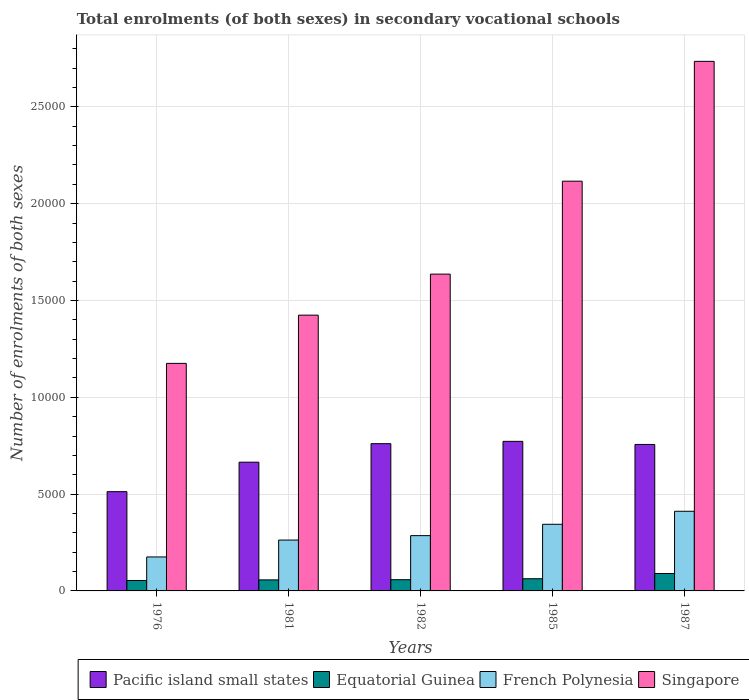How many bars are there on the 4th tick from the right?
Your answer should be very brief. 4. What is the label of the 2nd group of bars from the left?
Your answer should be compact. 1981. What is the number of enrolments in secondary schools in Equatorial Guinea in 1981?
Your response must be concise. 570. Across all years, what is the maximum number of enrolments in secondary schools in Pacific island small states?
Make the answer very short. 7724.29. Across all years, what is the minimum number of enrolments in secondary schools in French Polynesia?
Provide a short and direct response. 1755. In which year was the number of enrolments in secondary schools in Singapore minimum?
Your answer should be very brief. 1976. What is the total number of enrolments in secondary schools in French Polynesia in the graph?
Your answer should be compact. 1.48e+04. What is the difference between the number of enrolments in secondary schools in Pacific island small states in 1976 and that in 1981?
Your response must be concise. -1522.4. What is the difference between the number of enrolments in secondary schools in Pacific island small states in 1987 and the number of enrolments in secondary schools in Equatorial Guinea in 1985?
Your answer should be compact. 6934.79. What is the average number of enrolments in secondary schools in Singapore per year?
Provide a succinct answer. 1.82e+04. In the year 1982, what is the difference between the number of enrolments in secondary schools in French Polynesia and number of enrolments in secondary schools in Singapore?
Make the answer very short. -1.35e+04. What is the ratio of the number of enrolments in secondary schools in Singapore in 1976 to that in 1981?
Make the answer very short. 0.83. Is the difference between the number of enrolments in secondary schools in French Polynesia in 1981 and 1982 greater than the difference between the number of enrolments in secondary schools in Singapore in 1981 and 1982?
Provide a succinct answer. Yes. What is the difference between the highest and the second highest number of enrolments in secondary schools in French Polynesia?
Offer a very short reply. 672. What is the difference between the highest and the lowest number of enrolments in secondary schools in Equatorial Guinea?
Offer a terse response. 361. Is the sum of the number of enrolments in secondary schools in Equatorial Guinea in 1982 and 1987 greater than the maximum number of enrolments in secondary schools in Pacific island small states across all years?
Provide a succinct answer. No. Is it the case that in every year, the sum of the number of enrolments in secondary schools in French Polynesia and number of enrolments in secondary schools in Pacific island small states is greater than the sum of number of enrolments in secondary schools in Singapore and number of enrolments in secondary schools in Equatorial Guinea?
Give a very brief answer. No. What does the 4th bar from the left in 1981 represents?
Your answer should be very brief. Singapore. What does the 4th bar from the right in 1985 represents?
Give a very brief answer. Pacific island small states. How many bars are there?
Give a very brief answer. 20. Are all the bars in the graph horizontal?
Ensure brevity in your answer.  No. Are the values on the major ticks of Y-axis written in scientific E-notation?
Your answer should be compact. No. Does the graph contain any zero values?
Keep it short and to the point. No. What is the title of the graph?
Offer a terse response. Total enrolments (of both sexes) in secondary vocational schools. Does "Tuvalu" appear as one of the legend labels in the graph?
Your response must be concise. No. What is the label or title of the Y-axis?
Your response must be concise. Number of enrolments of both sexes. What is the Number of enrolments of both sexes in Pacific island small states in 1976?
Keep it short and to the point. 5126.3. What is the Number of enrolments of both sexes of Equatorial Guinea in 1976?
Offer a terse response. 539. What is the Number of enrolments of both sexes of French Polynesia in 1976?
Provide a short and direct response. 1755. What is the Number of enrolments of both sexes in Singapore in 1976?
Your answer should be very brief. 1.18e+04. What is the Number of enrolments of both sexes in Pacific island small states in 1981?
Ensure brevity in your answer.  6648.7. What is the Number of enrolments of both sexes of Equatorial Guinea in 1981?
Your answer should be very brief. 570. What is the Number of enrolments of both sexes in French Polynesia in 1981?
Your response must be concise. 2627. What is the Number of enrolments of both sexes of Singapore in 1981?
Your answer should be compact. 1.42e+04. What is the Number of enrolments of both sexes of Pacific island small states in 1982?
Offer a very short reply. 7604.77. What is the Number of enrolments of both sexes in Equatorial Guinea in 1982?
Give a very brief answer. 580. What is the Number of enrolments of both sexes of French Polynesia in 1982?
Offer a very short reply. 2855. What is the Number of enrolments of both sexes in Singapore in 1982?
Offer a terse response. 1.64e+04. What is the Number of enrolments of both sexes of Pacific island small states in 1985?
Your answer should be compact. 7724.29. What is the Number of enrolments of both sexes in Equatorial Guinea in 1985?
Make the answer very short. 630. What is the Number of enrolments of both sexes of French Polynesia in 1985?
Provide a succinct answer. 3441. What is the Number of enrolments of both sexes in Singapore in 1985?
Offer a terse response. 2.12e+04. What is the Number of enrolments of both sexes of Pacific island small states in 1987?
Your answer should be compact. 7564.79. What is the Number of enrolments of both sexes in Equatorial Guinea in 1987?
Ensure brevity in your answer.  900. What is the Number of enrolments of both sexes in French Polynesia in 1987?
Your response must be concise. 4113. What is the Number of enrolments of both sexes in Singapore in 1987?
Provide a short and direct response. 2.73e+04. Across all years, what is the maximum Number of enrolments of both sexes in Pacific island small states?
Keep it short and to the point. 7724.29. Across all years, what is the maximum Number of enrolments of both sexes of Equatorial Guinea?
Give a very brief answer. 900. Across all years, what is the maximum Number of enrolments of both sexes in French Polynesia?
Provide a short and direct response. 4113. Across all years, what is the maximum Number of enrolments of both sexes of Singapore?
Offer a very short reply. 2.73e+04. Across all years, what is the minimum Number of enrolments of both sexes in Pacific island small states?
Ensure brevity in your answer.  5126.3. Across all years, what is the minimum Number of enrolments of both sexes of Equatorial Guinea?
Provide a succinct answer. 539. Across all years, what is the minimum Number of enrolments of both sexes of French Polynesia?
Provide a short and direct response. 1755. Across all years, what is the minimum Number of enrolments of both sexes in Singapore?
Give a very brief answer. 1.18e+04. What is the total Number of enrolments of both sexes of Pacific island small states in the graph?
Your answer should be compact. 3.47e+04. What is the total Number of enrolments of both sexes of Equatorial Guinea in the graph?
Offer a very short reply. 3219. What is the total Number of enrolments of both sexes in French Polynesia in the graph?
Your answer should be very brief. 1.48e+04. What is the total Number of enrolments of both sexes in Singapore in the graph?
Keep it short and to the point. 9.09e+04. What is the difference between the Number of enrolments of both sexes of Pacific island small states in 1976 and that in 1981?
Your answer should be very brief. -1522.4. What is the difference between the Number of enrolments of both sexes in Equatorial Guinea in 1976 and that in 1981?
Offer a very short reply. -31. What is the difference between the Number of enrolments of both sexes of French Polynesia in 1976 and that in 1981?
Ensure brevity in your answer.  -872. What is the difference between the Number of enrolments of both sexes of Singapore in 1976 and that in 1981?
Your response must be concise. -2491. What is the difference between the Number of enrolments of both sexes in Pacific island small states in 1976 and that in 1982?
Your answer should be very brief. -2478.46. What is the difference between the Number of enrolments of both sexes of Equatorial Guinea in 1976 and that in 1982?
Offer a very short reply. -41. What is the difference between the Number of enrolments of both sexes in French Polynesia in 1976 and that in 1982?
Offer a terse response. -1100. What is the difference between the Number of enrolments of both sexes in Singapore in 1976 and that in 1982?
Keep it short and to the point. -4610. What is the difference between the Number of enrolments of both sexes of Pacific island small states in 1976 and that in 1985?
Provide a short and direct response. -2597.98. What is the difference between the Number of enrolments of both sexes in Equatorial Guinea in 1976 and that in 1985?
Your response must be concise. -91. What is the difference between the Number of enrolments of both sexes of French Polynesia in 1976 and that in 1985?
Give a very brief answer. -1686. What is the difference between the Number of enrolments of both sexes of Singapore in 1976 and that in 1985?
Provide a succinct answer. -9410. What is the difference between the Number of enrolments of both sexes of Pacific island small states in 1976 and that in 1987?
Your answer should be compact. -2438.49. What is the difference between the Number of enrolments of both sexes in Equatorial Guinea in 1976 and that in 1987?
Provide a short and direct response. -361. What is the difference between the Number of enrolments of both sexes in French Polynesia in 1976 and that in 1987?
Your answer should be very brief. -2358. What is the difference between the Number of enrolments of both sexes of Singapore in 1976 and that in 1987?
Offer a very short reply. -1.56e+04. What is the difference between the Number of enrolments of both sexes in Pacific island small states in 1981 and that in 1982?
Your answer should be very brief. -956.06. What is the difference between the Number of enrolments of both sexes of French Polynesia in 1981 and that in 1982?
Make the answer very short. -228. What is the difference between the Number of enrolments of both sexes in Singapore in 1981 and that in 1982?
Offer a very short reply. -2119. What is the difference between the Number of enrolments of both sexes of Pacific island small states in 1981 and that in 1985?
Provide a succinct answer. -1075.59. What is the difference between the Number of enrolments of both sexes of Equatorial Guinea in 1981 and that in 1985?
Keep it short and to the point. -60. What is the difference between the Number of enrolments of both sexes of French Polynesia in 1981 and that in 1985?
Your response must be concise. -814. What is the difference between the Number of enrolments of both sexes of Singapore in 1981 and that in 1985?
Keep it short and to the point. -6919. What is the difference between the Number of enrolments of both sexes in Pacific island small states in 1981 and that in 1987?
Make the answer very short. -916.09. What is the difference between the Number of enrolments of both sexes in Equatorial Guinea in 1981 and that in 1987?
Keep it short and to the point. -330. What is the difference between the Number of enrolments of both sexes of French Polynesia in 1981 and that in 1987?
Offer a very short reply. -1486. What is the difference between the Number of enrolments of both sexes of Singapore in 1981 and that in 1987?
Your answer should be compact. -1.31e+04. What is the difference between the Number of enrolments of both sexes in Pacific island small states in 1982 and that in 1985?
Keep it short and to the point. -119.52. What is the difference between the Number of enrolments of both sexes of French Polynesia in 1982 and that in 1985?
Your response must be concise. -586. What is the difference between the Number of enrolments of both sexes of Singapore in 1982 and that in 1985?
Provide a succinct answer. -4800. What is the difference between the Number of enrolments of both sexes of Pacific island small states in 1982 and that in 1987?
Keep it short and to the point. 39.98. What is the difference between the Number of enrolments of both sexes of Equatorial Guinea in 1982 and that in 1987?
Your answer should be compact. -320. What is the difference between the Number of enrolments of both sexes of French Polynesia in 1982 and that in 1987?
Offer a terse response. -1258. What is the difference between the Number of enrolments of both sexes in Singapore in 1982 and that in 1987?
Offer a terse response. -1.10e+04. What is the difference between the Number of enrolments of both sexes in Pacific island small states in 1985 and that in 1987?
Your answer should be compact. 159.5. What is the difference between the Number of enrolments of both sexes of Equatorial Guinea in 1985 and that in 1987?
Your response must be concise. -270. What is the difference between the Number of enrolments of both sexes of French Polynesia in 1985 and that in 1987?
Your answer should be compact. -672. What is the difference between the Number of enrolments of both sexes of Singapore in 1985 and that in 1987?
Give a very brief answer. -6188. What is the difference between the Number of enrolments of both sexes of Pacific island small states in 1976 and the Number of enrolments of both sexes of Equatorial Guinea in 1981?
Provide a succinct answer. 4556.3. What is the difference between the Number of enrolments of both sexes in Pacific island small states in 1976 and the Number of enrolments of both sexes in French Polynesia in 1981?
Offer a very short reply. 2499.3. What is the difference between the Number of enrolments of both sexes in Pacific island small states in 1976 and the Number of enrolments of both sexes in Singapore in 1981?
Ensure brevity in your answer.  -9115.7. What is the difference between the Number of enrolments of both sexes of Equatorial Guinea in 1976 and the Number of enrolments of both sexes of French Polynesia in 1981?
Provide a succinct answer. -2088. What is the difference between the Number of enrolments of both sexes of Equatorial Guinea in 1976 and the Number of enrolments of both sexes of Singapore in 1981?
Give a very brief answer. -1.37e+04. What is the difference between the Number of enrolments of both sexes in French Polynesia in 1976 and the Number of enrolments of both sexes in Singapore in 1981?
Give a very brief answer. -1.25e+04. What is the difference between the Number of enrolments of both sexes of Pacific island small states in 1976 and the Number of enrolments of both sexes of Equatorial Guinea in 1982?
Provide a short and direct response. 4546.3. What is the difference between the Number of enrolments of both sexes of Pacific island small states in 1976 and the Number of enrolments of both sexes of French Polynesia in 1982?
Your answer should be compact. 2271.3. What is the difference between the Number of enrolments of both sexes of Pacific island small states in 1976 and the Number of enrolments of both sexes of Singapore in 1982?
Your answer should be compact. -1.12e+04. What is the difference between the Number of enrolments of both sexes in Equatorial Guinea in 1976 and the Number of enrolments of both sexes in French Polynesia in 1982?
Give a very brief answer. -2316. What is the difference between the Number of enrolments of both sexes of Equatorial Guinea in 1976 and the Number of enrolments of both sexes of Singapore in 1982?
Your answer should be compact. -1.58e+04. What is the difference between the Number of enrolments of both sexes in French Polynesia in 1976 and the Number of enrolments of both sexes in Singapore in 1982?
Offer a very short reply. -1.46e+04. What is the difference between the Number of enrolments of both sexes of Pacific island small states in 1976 and the Number of enrolments of both sexes of Equatorial Guinea in 1985?
Provide a short and direct response. 4496.3. What is the difference between the Number of enrolments of both sexes in Pacific island small states in 1976 and the Number of enrolments of both sexes in French Polynesia in 1985?
Offer a terse response. 1685.3. What is the difference between the Number of enrolments of both sexes of Pacific island small states in 1976 and the Number of enrolments of both sexes of Singapore in 1985?
Ensure brevity in your answer.  -1.60e+04. What is the difference between the Number of enrolments of both sexes in Equatorial Guinea in 1976 and the Number of enrolments of both sexes in French Polynesia in 1985?
Give a very brief answer. -2902. What is the difference between the Number of enrolments of both sexes of Equatorial Guinea in 1976 and the Number of enrolments of both sexes of Singapore in 1985?
Your answer should be compact. -2.06e+04. What is the difference between the Number of enrolments of both sexes of French Polynesia in 1976 and the Number of enrolments of both sexes of Singapore in 1985?
Keep it short and to the point. -1.94e+04. What is the difference between the Number of enrolments of both sexes in Pacific island small states in 1976 and the Number of enrolments of both sexes in Equatorial Guinea in 1987?
Give a very brief answer. 4226.3. What is the difference between the Number of enrolments of both sexes of Pacific island small states in 1976 and the Number of enrolments of both sexes of French Polynesia in 1987?
Give a very brief answer. 1013.3. What is the difference between the Number of enrolments of both sexes of Pacific island small states in 1976 and the Number of enrolments of both sexes of Singapore in 1987?
Your answer should be compact. -2.22e+04. What is the difference between the Number of enrolments of both sexes of Equatorial Guinea in 1976 and the Number of enrolments of both sexes of French Polynesia in 1987?
Your answer should be very brief. -3574. What is the difference between the Number of enrolments of both sexes of Equatorial Guinea in 1976 and the Number of enrolments of both sexes of Singapore in 1987?
Make the answer very short. -2.68e+04. What is the difference between the Number of enrolments of both sexes in French Polynesia in 1976 and the Number of enrolments of both sexes in Singapore in 1987?
Provide a succinct answer. -2.56e+04. What is the difference between the Number of enrolments of both sexes of Pacific island small states in 1981 and the Number of enrolments of both sexes of Equatorial Guinea in 1982?
Keep it short and to the point. 6068.7. What is the difference between the Number of enrolments of both sexes of Pacific island small states in 1981 and the Number of enrolments of both sexes of French Polynesia in 1982?
Offer a terse response. 3793.7. What is the difference between the Number of enrolments of both sexes of Pacific island small states in 1981 and the Number of enrolments of both sexes of Singapore in 1982?
Give a very brief answer. -9712.3. What is the difference between the Number of enrolments of both sexes in Equatorial Guinea in 1981 and the Number of enrolments of both sexes in French Polynesia in 1982?
Provide a succinct answer. -2285. What is the difference between the Number of enrolments of both sexes of Equatorial Guinea in 1981 and the Number of enrolments of both sexes of Singapore in 1982?
Provide a succinct answer. -1.58e+04. What is the difference between the Number of enrolments of both sexes in French Polynesia in 1981 and the Number of enrolments of both sexes in Singapore in 1982?
Give a very brief answer. -1.37e+04. What is the difference between the Number of enrolments of both sexes in Pacific island small states in 1981 and the Number of enrolments of both sexes in Equatorial Guinea in 1985?
Offer a terse response. 6018.7. What is the difference between the Number of enrolments of both sexes in Pacific island small states in 1981 and the Number of enrolments of both sexes in French Polynesia in 1985?
Ensure brevity in your answer.  3207.7. What is the difference between the Number of enrolments of both sexes of Pacific island small states in 1981 and the Number of enrolments of both sexes of Singapore in 1985?
Offer a very short reply. -1.45e+04. What is the difference between the Number of enrolments of both sexes of Equatorial Guinea in 1981 and the Number of enrolments of both sexes of French Polynesia in 1985?
Keep it short and to the point. -2871. What is the difference between the Number of enrolments of both sexes in Equatorial Guinea in 1981 and the Number of enrolments of both sexes in Singapore in 1985?
Provide a succinct answer. -2.06e+04. What is the difference between the Number of enrolments of both sexes of French Polynesia in 1981 and the Number of enrolments of both sexes of Singapore in 1985?
Ensure brevity in your answer.  -1.85e+04. What is the difference between the Number of enrolments of both sexes of Pacific island small states in 1981 and the Number of enrolments of both sexes of Equatorial Guinea in 1987?
Give a very brief answer. 5748.7. What is the difference between the Number of enrolments of both sexes of Pacific island small states in 1981 and the Number of enrolments of both sexes of French Polynesia in 1987?
Provide a succinct answer. 2535.7. What is the difference between the Number of enrolments of both sexes in Pacific island small states in 1981 and the Number of enrolments of both sexes in Singapore in 1987?
Ensure brevity in your answer.  -2.07e+04. What is the difference between the Number of enrolments of both sexes in Equatorial Guinea in 1981 and the Number of enrolments of both sexes in French Polynesia in 1987?
Your response must be concise. -3543. What is the difference between the Number of enrolments of both sexes in Equatorial Guinea in 1981 and the Number of enrolments of both sexes in Singapore in 1987?
Provide a succinct answer. -2.68e+04. What is the difference between the Number of enrolments of both sexes of French Polynesia in 1981 and the Number of enrolments of both sexes of Singapore in 1987?
Offer a terse response. -2.47e+04. What is the difference between the Number of enrolments of both sexes of Pacific island small states in 1982 and the Number of enrolments of both sexes of Equatorial Guinea in 1985?
Give a very brief answer. 6974.77. What is the difference between the Number of enrolments of both sexes in Pacific island small states in 1982 and the Number of enrolments of both sexes in French Polynesia in 1985?
Provide a short and direct response. 4163.77. What is the difference between the Number of enrolments of both sexes in Pacific island small states in 1982 and the Number of enrolments of both sexes in Singapore in 1985?
Offer a terse response. -1.36e+04. What is the difference between the Number of enrolments of both sexes in Equatorial Guinea in 1982 and the Number of enrolments of both sexes in French Polynesia in 1985?
Your answer should be compact. -2861. What is the difference between the Number of enrolments of both sexes in Equatorial Guinea in 1982 and the Number of enrolments of both sexes in Singapore in 1985?
Provide a short and direct response. -2.06e+04. What is the difference between the Number of enrolments of both sexes of French Polynesia in 1982 and the Number of enrolments of both sexes of Singapore in 1985?
Ensure brevity in your answer.  -1.83e+04. What is the difference between the Number of enrolments of both sexes of Pacific island small states in 1982 and the Number of enrolments of both sexes of Equatorial Guinea in 1987?
Provide a succinct answer. 6704.77. What is the difference between the Number of enrolments of both sexes of Pacific island small states in 1982 and the Number of enrolments of both sexes of French Polynesia in 1987?
Make the answer very short. 3491.77. What is the difference between the Number of enrolments of both sexes of Pacific island small states in 1982 and the Number of enrolments of both sexes of Singapore in 1987?
Your answer should be compact. -1.97e+04. What is the difference between the Number of enrolments of both sexes in Equatorial Guinea in 1982 and the Number of enrolments of both sexes in French Polynesia in 1987?
Give a very brief answer. -3533. What is the difference between the Number of enrolments of both sexes of Equatorial Guinea in 1982 and the Number of enrolments of both sexes of Singapore in 1987?
Offer a terse response. -2.68e+04. What is the difference between the Number of enrolments of both sexes of French Polynesia in 1982 and the Number of enrolments of both sexes of Singapore in 1987?
Your answer should be very brief. -2.45e+04. What is the difference between the Number of enrolments of both sexes in Pacific island small states in 1985 and the Number of enrolments of both sexes in Equatorial Guinea in 1987?
Your answer should be very brief. 6824.29. What is the difference between the Number of enrolments of both sexes in Pacific island small states in 1985 and the Number of enrolments of both sexes in French Polynesia in 1987?
Provide a succinct answer. 3611.29. What is the difference between the Number of enrolments of both sexes of Pacific island small states in 1985 and the Number of enrolments of both sexes of Singapore in 1987?
Offer a very short reply. -1.96e+04. What is the difference between the Number of enrolments of both sexes of Equatorial Guinea in 1985 and the Number of enrolments of both sexes of French Polynesia in 1987?
Provide a short and direct response. -3483. What is the difference between the Number of enrolments of both sexes of Equatorial Guinea in 1985 and the Number of enrolments of both sexes of Singapore in 1987?
Provide a short and direct response. -2.67e+04. What is the difference between the Number of enrolments of both sexes in French Polynesia in 1985 and the Number of enrolments of both sexes in Singapore in 1987?
Your answer should be compact. -2.39e+04. What is the average Number of enrolments of both sexes in Pacific island small states per year?
Your response must be concise. 6933.77. What is the average Number of enrolments of both sexes in Equatorial Guinea per year?
Your response must be concise. 643.8. What is the average Number of enrolments of both sexes of French Polynesia per year?
Your response must be concise. 2958.2. What is the average Number of enrolments of both sexes of Singapore per year?
Your answer should be compact. 1.82e+04. In the year 1976, what is the difference between the Number of enrolments of both sexes in Pacific island small states and Number of enrolments of both sexes in Equatorial Guinea?
Your response must be concise. 4587.3. In the year 1976, what is the difference between the Number of enrolments of both sexes in Pacific island small states and Number of enrolments of both sexes in French Polynesia?
Provide a short and direct response. 3371.3. In the year 1976, what is the difference between the Number of enrolments of both sexes in Pacific island small states and Number of enrolments of both sexes in Singapore?
Keep it short and to the point. -6624.7. In the year 1976, what is the difference between the Number of enrolments of both sexes in Equatorial Guinea and Number of enrolments of both sexes in French Polynesia?
Give a very brief answer. -1216. In the year 1976, what is the difference between the Number of enrolments of both sexes in Equatorial Guinea and Number of enrolments of both sexes in Singapore?
Offer a very short reply. -1.12e+04. In the year 1976, what is the difference between the Number of enrolments of both sexes in French Polynesia and Number of enrolments of both sexes in Singapore?
Your response must be concise. -9996. In the year 1981, what is the difference between the Number of enrolments of both sexes in Pacific island small states and Number of enrolments of both sexes in Equatorial Guinea?
Provide a succinct answer. 6078.7. In the year 1981, what is the difference between the Number of enrolments of both sexes of Pacific island small states and Number of enrolments of both sexes of French Polynesia?
Your response must be concise. 4021.7. In the year 1981, what is the difference between the Number of enrolments of both sexes of Pacific island small states and Number of enrolments of both sexes of Singapore?
Ensure brevity in your answer.  -7593.3. In the year 1981, what is the difference between the Number of enrolments of both sexes in Equatorial Guinea and Number of enrolments of both sexes in French Polynesia?
Ensure brevity in your answer.  -2057. In the year 1981, what is the difference between the Number of enrolments of both sexes in Equatorial Guinea and Number of enrolments of both sexes in Singapore?
Give a very brief answer. -1.37e+04. In the year 1981, what is the difference between the Number of enrolments of both sexes in French Polynesia and Number of enrolments of both sexes in Singapore?
Provide a short and direct response. -1.16e+04. In the year 1982, what is the difference between the Number of enrolments of both sexes of Pacific island small states and Number of enrolments of both sexes of Equatorial Guinea?
Keep it short and to the point. 7024.77. In the year 1982, what is the difference between the Number of enrolments of both sexes of Pacific island small states and Number of enrolments of both sexes of French Polynesia?
Ensure brevity in your answer.  4749.77. In the year 1982, what is the difference between the Number of enrolments of both sexes of Pacific island small states and Number of enrolments of both sexes of Singapore?
Make the answer very short. -8756.23. In the year 1982, what is the difference between the Number of enrolments of both sexes in Equatorial Guinea and Number of enrolments of both sexes in French Polynesia?
Give a very brief answer. -2275. In the year 1982, what is the difference between the Number of enrolments of both sexes of Equatorial Guinea and Number of enrolments of both sexes of Singapore?
Offer a terse response. -1.58e+04. In the year 1982, what is the difference between the Number of enrolments of both sexes in French Polynesia and Number of enrolments of both sexes in Singapore?
Provide a succinct answer. -1.35e+04. In the year 1985, what is the difference between the Number of enrolments of both sexes of Pacific island small states and Number of enrolments of both sexes of Equatorial Guinea?
Provide a short and direct response. 7094.29. In the year 1985, what is the difference between the Number of enrolments of both sexes of Pacific island small states and Number of enrolments of both sexes of French Polynesia?
Offer a terse response. 4283.29. In the year 1985, what is the difference between the Number of enrolments of both sexes in Pacific island small states and Number of enrolments of both sexes in Singapore?
Ensure brevity in your answer.  -1.34e+04. In the year 1985, what is the difference between the Number of enrolments of both sexes in Equatorial Guinea and Number of enrolments of both sexes in French Polynesia?
Give a very brief answer. -2811. In the year 1985, what is the difference between the Number of enrolments of both sexes of Equatorial Guinea and Number of enrolments of both sexes of Singapore?
Your response must be concise. -2.05e+04. In the year 1985, what is the difference between the Number of enrolments of both sexes of French Polynesia and Number of enrolments of both sexes of Singapore?
Ensure brevity in your answer.  -1.77e+04. In the year 1987, what is the difference between the Number of enrolments of both sexes of Pacific island small states and Number of enrolments of both sexes of Equatorial Guinea?
Your answer should be compact. 6664.79. In the year 1987, what is the difference between the Number of enrolments of both sexes in Pacific island small states and Number of enrolments of both sexes in French Polynesia?
Provide a succinct answer. 3451.79. In the year 1987, what is the difference between the Number of enrolments of both sexes of Pacific island small states and Number of enrolments of both sexes of Singapore?
Your answer should be compact. -1.98e+04. In the year 1987, what is the difference between the Number of enrolments of both sexes in Equatorial Guinea and Number of enrolments of both sexes in French Polynesia?
Ensure brevity in your answer.  -3213. In the year 1987, what is the difference between the Number of enrolments of both sexes of Equatorial Guinea and Number of enrolments of both sexes of Singapore?
Your answer should be compact. -2.64e+04. In the year 1987, what is the difference between the Number of enrolments of both sexes in French Polynesia and Number of enrolments of both sexes in Singapore?
Provide a succinct answer. -2.32e+04. What is the ratio of the Number of enrolments of both sexes of Pacific island small states in 1976 to that in 1981?
Keep it short and to the point. 0.77. What is the ratio of the Number of enrolments of both sexes of Equatorial Guinea in 1976 to that in 1981?
Your answer should be very brief. 0.95. What is the ratio of the Number of enrolments of both sexes in French Polynesia in 1976 to that in 1981?
Offer a terse response. 0.67. What is the ratio of the Number of enrolments of both sexes in Singapore in 1976 to that in 1981?
Offer a very short reply. 0.83. What is the ratio of the Number of enrolments of both sexes in Pacific island small states in 1976 to that in 1982?
Your response must be concise. 0.67. What is the ratio of the Number of enrolments of both sexes in Equatorial Guinea in 1976 to that in 1982?
Make the answer very short. 0.93. What is the ratio of the Number of enrolments of both sexes in French Polynesia in 1976 to that in 1982?
Offer a terse response. 0.61. What is the ratio of the Number of enrolments of both sexes in Singapore in 1976 to that in 1982?
Provide a short and direct response. 0.72. What is the ratio of the Number of enrolments of both sexes in Pacific island small states in 1976 to that in 1985?
Give a very brief answer. 0.66. What is the ratio of the Number of enrolments of both sexes of Equatorial Guinea in 1976 to that in 1985?
Provide a short and direct response. 0.86. What is the ratio of the Number of enrolments of both sexes in French Polynesia in 1976 to that in 1985?
Your answer should be very brief. 0.51. What is the ratio of the Number of enrolments of both sexes in Singapore in 1976 to that in 1985?
Ensure brevity in your answer.  0.56. What is the ratio of the Number of enrolments of both sexes of Pacific island small states in 1976 to that in 1987?
Make the answer very short. 0.68. What is the ratio of the Number of enrolments of both sexes in Equatorial Guinea in 1976 to that in 1987?
Provide a short and direct response. 0.6. What is the ratio of the Number of enrolments of both sexes of French Polynesia in 1976 to that in 1987?
Give a very brief answer. 0.43. What is the ratio of the Number of enrolments of both sexes in Singapore in 1976 to that in 1987?
Your response must be concise. 0.43. What is the ratio of the Number of enrolments of both sexes in Pacific island small states in 1981 to that in 1982?
Provide a succinct answer. 0.87. What is the ratio of the Number of enrolments of both sexes in Equatorial Guinea in 1981 to that in 1982?
Your response must be concise. 0.98. What is the ratio of the Number of enrolments of both sexes in French Polynesia in 1981 to that in 1982?
Your response must be concise. 0.92. What is the ratio of the Number of enrolments of both sexes of Singapore in 1981 to that in 1982?
Provide a succinct answer. 0.87. What is the ratio of the Number of enrolments of both sexes of Pacific island small states in 1981 to that in 1985?
Your answer should be compact. 0.86. What is the ratio of the Number of enrolments of both sexes in Equatorial Guinea in 1981 to that in 1985?
Your answer should be compact. 0.9. What is the ratio of the Number of enrolments of both sexes of French Polynesia in 1981 to that in 1985?
Keep it short and to the point. 0.76. What is the ratio of the Number of enrolments of both sexes of Singapore in 1981 to that in 1985?
Keep it short and to the point. 0.67. What is the ratio of the Number of enrolments of both sexes of Pacific island small states in 1981 to that in 1987?
Offer a very short reply. 0.88. What is the ratio of the Number of enrolments of both sexes of Equatorial Guinea in 1981 to that in 1987?
Offer a terse response. 0.63. What is the ratio of the Number of enrolments of both sexes of French Polynesia in 1981 to that in 1987?
Your answer should be compact. 0.64. What is the ratio of the Number of enrolments of both sexes in Singapore in 1981 to that in 1987?
Offer a terse response. 0.52. What is the ratio of the Number of enrolments of both sexes of Pacific island small states in 1982 to that in 1985?
Your response must be concise. 0.98. What is the ratio of the Number of enrolments of both sexes in Equatorial Guinea in 1982 to that in 1985?
Keep it short and to the point. 0.92. What is the ratio of the Number of enrolments of both sexes of French Polynesia in 1982 to that in 1985?
Provide a succinct answer. 0.83. What is the ratio of the Number of enrolments of both sexes in Singapore in 1982 to that in 1985?
Ensure brevity in your answer.  0.77. What is the ratio of the Number of enrolments of both sexes in Pacific island small states in 1982 to that in 1987?
Your response must be concise. 1.01. What is the ratio of the Number of enrolments of both sexes of Equatorial Guinea in 1982 to that in 1987?
Ensure brevity in your answer.  0.64. What is the ratio of the Number of enrolments of both sexes in French Polynesia in 1982 to that in 1987?
Offer a very short reply. 0.69. What is the ratio of the Number of enrolments of both sexes of Singapore in 1982 to that in 1987?
Keep it short and to the point. 0.6. What is the ratio of the Number of enrolments of both sexes in Pacific island small states in 1985 to that in 1987?
Make the answer very short. 1.02. What is the ratio of the Number of enrolments of both sexes of Equatorial Guinea in 1985 to that in 1987?
Keep it short and to the point. 0.7. What is the ratio of the Number of enrolments of both sexes in French Polynesia in 1985 to that in 1987?
Your answer should be very brief. 0.84. What is the ratio of the Number of enrolments of both sexes in Singapore in 1985 to that in 1987?
Make the answer very short. 0.77. What is the difference between the highest and the second highest Number of enrolments of both sexes in Pacific island small states?
Give a very brief answer. 119.52. What is the difference between the highest and the second highest Number of enrolments of both sexes of Equatorial Guinea?
Offer a very short reply. 270. What is the difference between the highest and the second highest Number of enrolments of both sexes of French Polynesia?
Offer a very short reply. 672. What is the difference between the highest and the second highest Number of enrolments of both sexes in Singapore?
Provide a succinct answer. 6188. What is the difference between the highest and the lowest Number of enrolments of both sexes of Pacific island small states?
Your answer should be compact. 2597.98. What is the difference between the highest and the lowest Number of enrolments of both sexes in Equatorial Guinea?
Keep it short and to the point. 361. What is the difference between the highest and the lowest Number of enrolments of both sexes in French Polynesia?
Offer a very short reply. 2358. What is the difference between the highest and the lowest Number of enrolments of both sexes of Singapore?
Provide a short and direct response. 1.56e+04. 